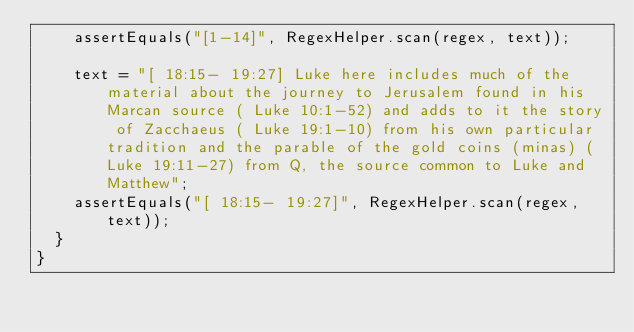<code> <loc_0><loc_0><loc_500><loc_500><_Java_>		assertEquals("[1-14]", RegexHelper.scan(regex, text));
		
		text = "[ 18:15- 19:27] Luke here includes much of the material about the journey to Jerusalem found in his Marcan source ( Luke 10:1-52) and adds to it the story of Zacchaeus ( Luke 19:1-10) from his own particular tradition and the parable of the gold coins (minas) ( Luke 19:11-27) from Q, the source common to Luke and Matthew";
		assertEquals("[ 18:15- 19:27]", RegexHelper.scan(regex, text));
	}
}</code> 